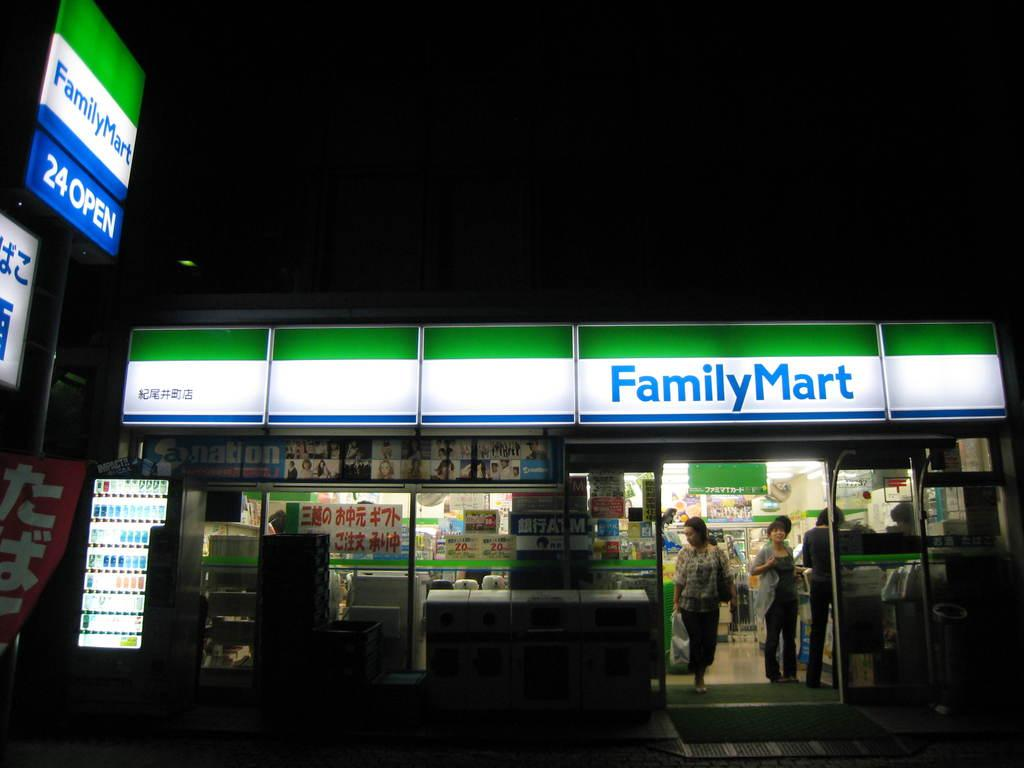<image>
Provide a brief description of the given image. A Family Mart that is lit up in the night 